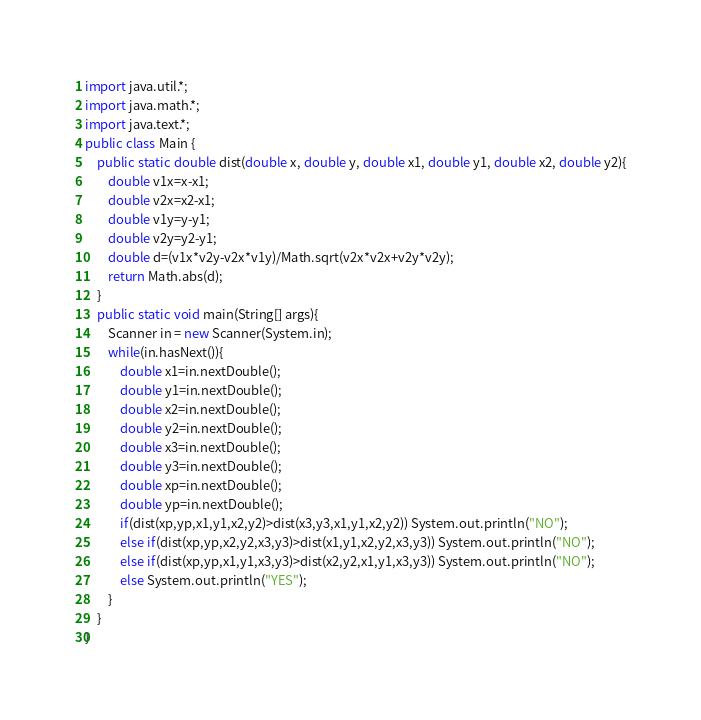Convert code to text. <code><loc_0><loc_0><loc_500><loc_500><_Java_>import java.util.*;
import java.math.*;
import java.text.*;
public class Main {
	public static double dist(double x, double y, double x1, double y1, double x2, double y2){
		double v1x=x-x1;
		double v2x=x2-x1;
		double v1y=y-y1;
		double v2y=y2-y1;
		double d=(v1x*v2y-v2x*v1y)/Math.sqrt(v2x*v2x+v2y*v2y);
		return Math.abs(d);
	}
	public static void main(String[] args){
		Scanner in = new Scanner(System.in);
		while(in.hasNext()){
			double x1=in.nextDouble();
			double y1=in.nextDouble();
			double x2=in.nextDouble();
			double y2=in.nextDouble();
			double x3=in.nextDouble();
			double y3=in.nextDouble();
			double xp=in.nextDouble();
			double yp=in.nextDouble();
			if(dist(xp,yp,x1,y1,x2,y2)>dist(x3,y3,x1,y1,x2,y2)) System.out.println("NO");
			else if(dist(xp,yp,x2,y2,x3,y3)>dist(x1,y1,x2,y2,x3,y3)) System.out.println("NO");
			else if(dist(xp,yp,x1,y1,x3,y3)>dist(x2,y2,x1,y1,x3,y3)) System.out.println("NO");
			else System.out.println("YES");
		}
	}
}</code> 